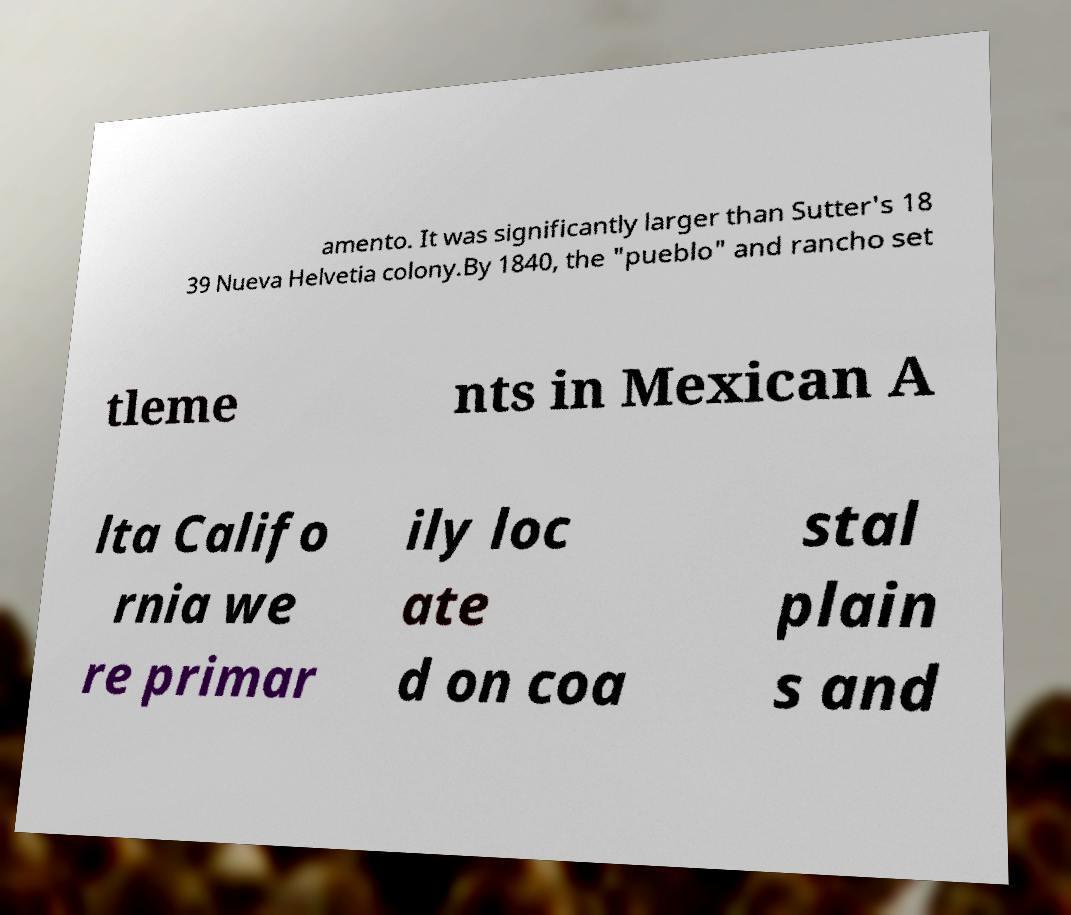There's text embedded in this image that I need extracted. Can you transcribe it verbatim? amento. It was significantly larger than Sutter's 18 39 Nueva Helvetia colony.By 1840, the "pueblo" and rancho set tleme nts in Mexican A lta Califo rnia we re primar ily loc ate d on coa stal plain s and 